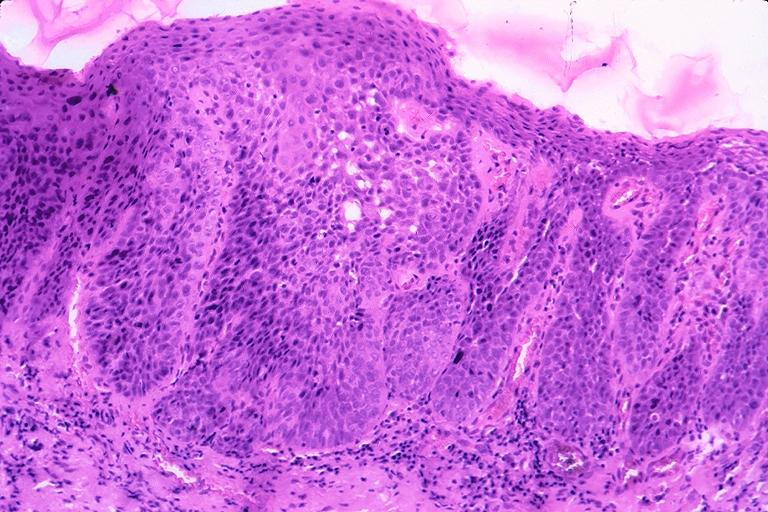does larynx show squamous cell carcinoma?
Answer the question using a single word or phrase. No 